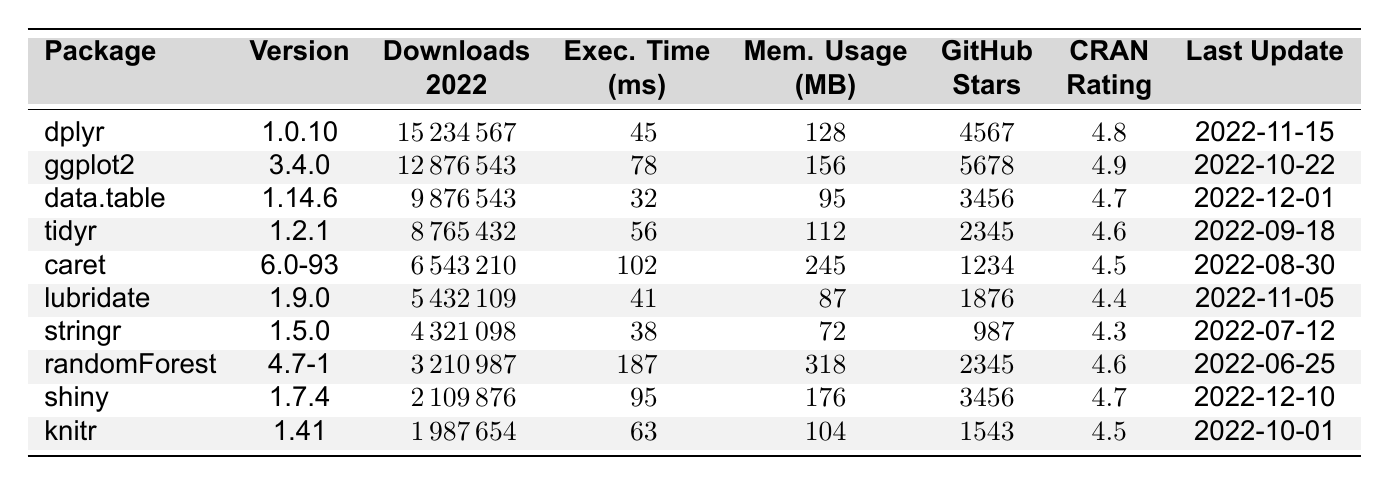What is the highest number of downloads for a package in 2022? By reviewing the "Downloads_2022" column, the package "dplyr" has the highest value at 15,234,567.
Answer: 15,234,567 Which package has the lowest execution time? Looking at the "Execution_Time_ms" column, "data.table" has the lowest execution time of 32 ms.
Answer: 32 ms What is the memory usage of the "randomForest" package? Referring to the "Memory_Usage_MB" column, "randomForest" uses 318 MB of memory.
Answer: 318 MB Is the version of "ggplot2" greater than 3.0.0? The version "3.4.0" is greater than 3.0.0.
Answer: Yes What is the average rating of the packages listed? Summing all ratings (4.8 + 4.9 + 4.7 + 4.6 + 4.5 + 4.4 + 4.3 + 4.6 + 4.7 + 4.5) results in 46.5, and dividing by 10 gives an average rating of 4.65.
Answer: 4.65 Which package has the most GitHub stars? The "ggplot2" package has the highest number of stars at 5,678, as seen in the "GitHub_Stars" column.
Answer: 5,678 What is the difference in memory usage between "caret" and "data.table"? The memory usage for "caret" is 245 MB and for "data.table" is 95 MB. The difference is 245 - 95 = 150 MB.
Answer: 150 MB How many packages were updated after August 30, 2022? The packages updated after this date are "dplyr" on November 15, "ggplot2" on October 22, "lubridate" on November 5, "data.table" on December 1, and "shiny" on December 10, totaling five packages.
Answer: 5 packages Which package has the highest execution time and how much is it? By inspecting the "Execution_Time_ms" column, "randomForest" has the highest execution time of 187 ms.
Answer: 187 ms Is there a package with a rating of 4.9, and which one is it? Yes, "ggplot2" has a rating of 4.9 as seen in the "CRAN_Rating" column.
Answer: Yes, ggplot2 What is the trend in execution times for packages based on their download numbers? The trend shows higher download numbers generally correlating with lower execution times, particularly "dplyr" with the highest downloads and low execution time of 45 ms. For a more in-depth analysis, one would consider specific ratios or conduct a regression analysis.
Answer: Generally lower execution times correlate with more downloads 